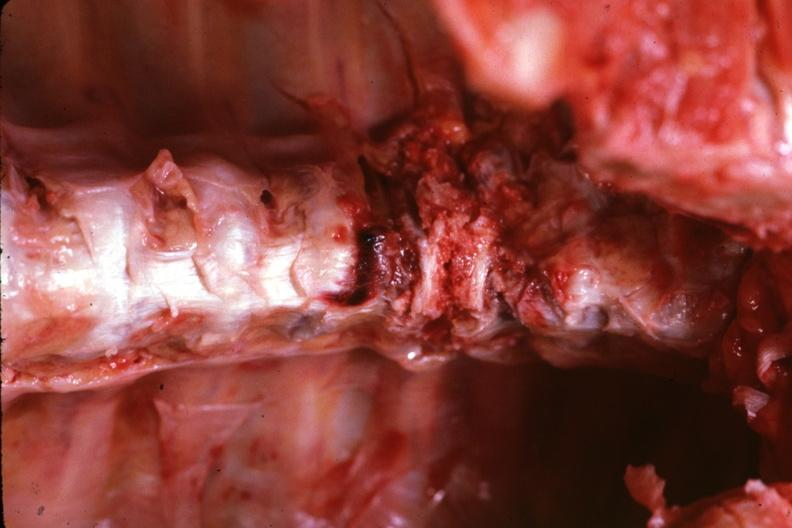what is present?
Answer the question using a single word or phrase. Joints 